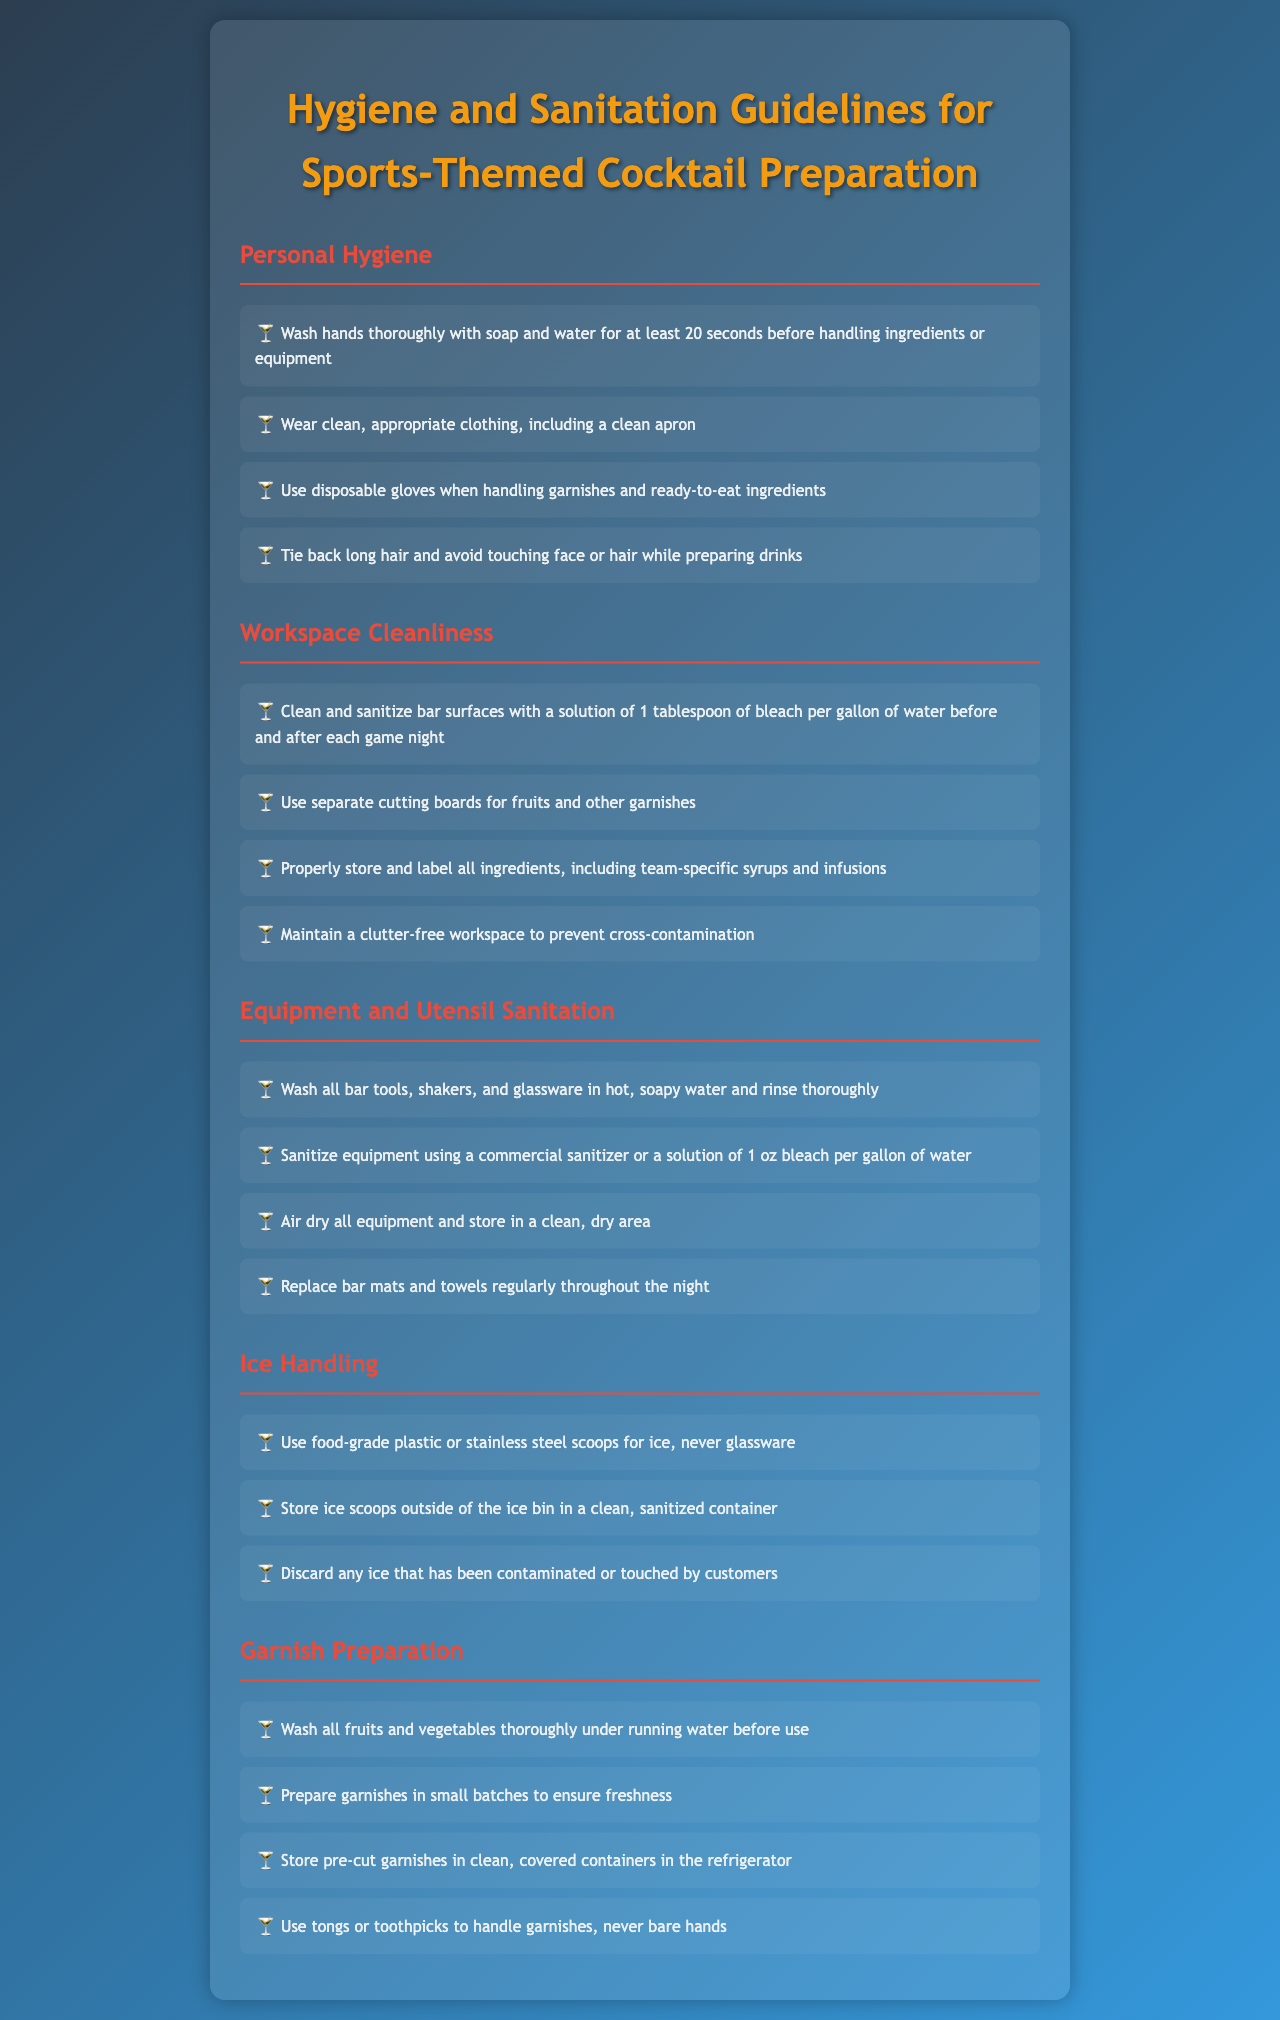What is the recommended time to wash hands? The document states that hands should be washed thoroughly with soap and water for at least 20 seconds.
Answer: 20 seconds What should be used for sanitizing bar tools? The document specifies using a commercial sanitizer or a solution of 1 oz bleach per gallon of water for sanitizing bar tools.
Answer: 1 oz bleach per gallon of water What is the primary purpose of wearing gloves when handling garnishes? Gloves are to be used when handling garnishes and ready-to-eat ingredients to prevent contamination.
Answer: Prevent contamination How should ice scoops be stored? Ice scoops should be stored outside of the ice bin in a clean, sanitized container.
Answer: Outside of the ice bin What should be done to fruits and vegetables before use? The document instructs to wash all fruits and vegetables thoroughly under running water before use.
Answer: Wash thoroughly Why should you maintain a clutter-free workspace? A clutter-free workspace helps prevent cross-contamination during cocktail preparation.
Answer: Prevent cross-contamination What type of clothing should be worn while preparing cocktails? The document advises wearing clean, appropriate clothing, including a clean apron.
Answer: Clean apron What is required for the cleanliness of cutting boards? Separate cutting boards should be used for fruits and other garnishes to ensure hygiene.
Answer: Separate cutting boards 